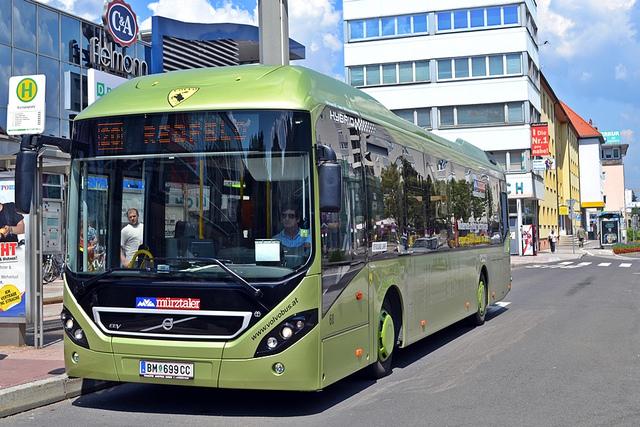What structure is directly on the other side of the bus's door?
Give a very brief answer. Building. What color is on the buses wheels?
Quick response, please. Green. Is this public transportation?
Write a very short answer. Yes. 